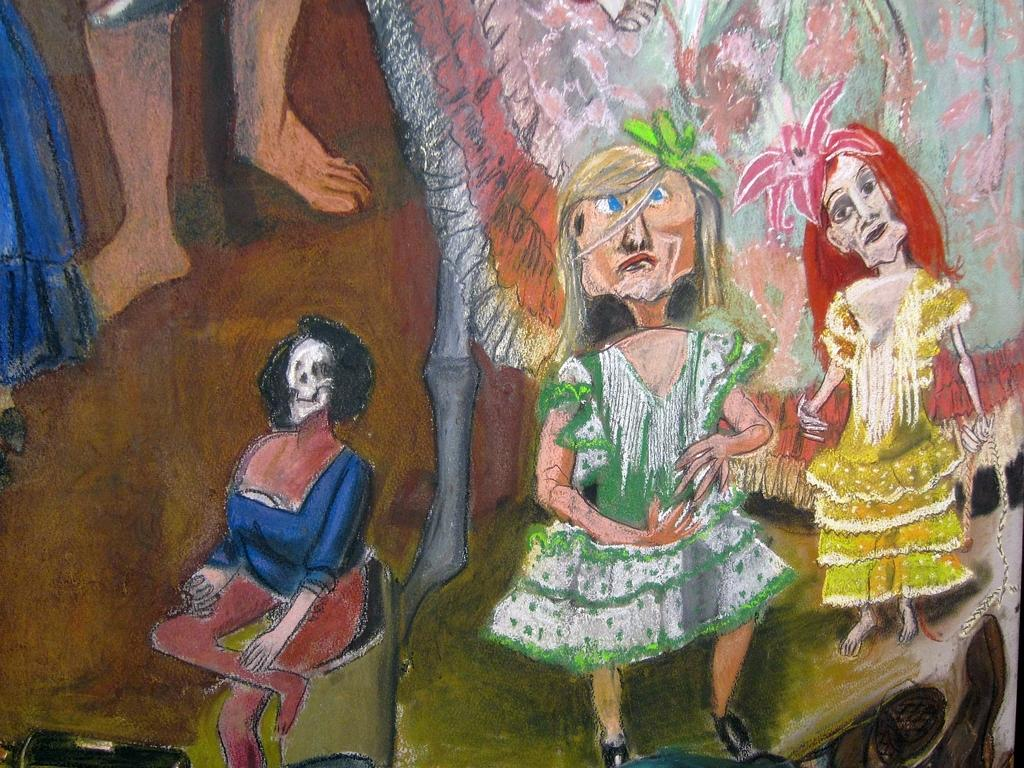What is the main subject of the image? There is a painting in the center of the image. What is happening in the painting? The painting depicts two persons standing and one person sitting. What body parts can be seen in the painting? Human legs are visible in the painting. Are there any other objects present in the painting besides the persons? Yes, there are a few other objects present in the painting. What is the price of the chain hanging from the board in the image? There is no chain or board present in the image; the main subject is a painting depicting persons and objects. 